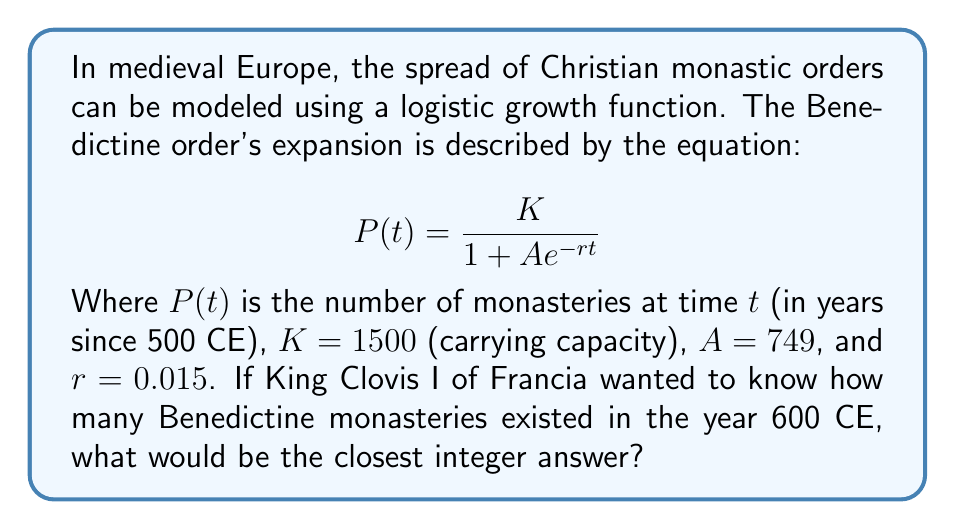What is the answer to this math problem? To solve this problem, we'll follow these steps:

1. Identify the given parameters:
   $K = 1500$
   $A = 749$
   $r = 0.015$
   $t = 100$ (since we're calculating for the year 600 CE, which is 100 years after 500 CE)

2. Substitute these values into the logistic growth equation:

   $$P(100) = \frac{1500}{1 + 749e^{-0.015 \cdot 100}}$$

3. Calculate the exponent:
   $-0.015 \cdot 100 = -1.5$

4. Simplify the equation:

   $$P(100) = \frac{1500}{1 + 749e^{-1.5}}$$

5. Calculate $e^{-1.5}$ (you can use a calculator for this):
   $e^{-1.5} \approx 0.2231$

6. Substitute this value:

   $$P(100) = \frac{1500}{1 + 749 \cdot 0.2231} = \frac{1500}{1 + 167.1019}$$

7. Simplify:

   $$P(100) = \frac{1500}{168.1019} \approx 8.9232$$

8. Round to the nearest integer:
   $P(100) \approx 9$

Therefore, the model predicts that there would be approximately 9 Benedictine monasteries in the year 600 CE.
Answer: 9 monasteries 